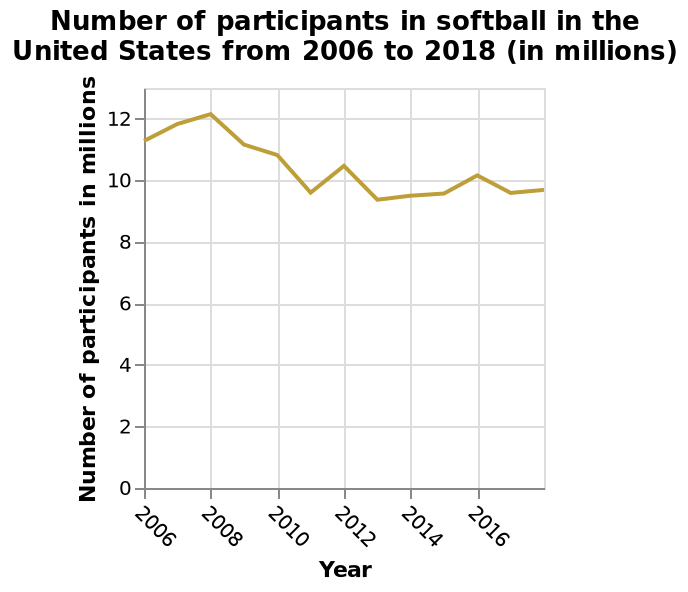<image>
Offer a thorough analysis of the image. The number of participants fell over the 12 year period. Participation varied and so the trend line fluctuates up and down over the period. Participation started at just over 11 million and finished at just under 10 million. What was the initial number of participants? The initial number of participants was just over 11 million. Did the number of participants rise over the 12 year period? No.The number of participants fell over the 12 year period. Participation varied and so the trend line fluctuates up and down over the period. Participation started at just over 11 million and finished at just under 10 million. 